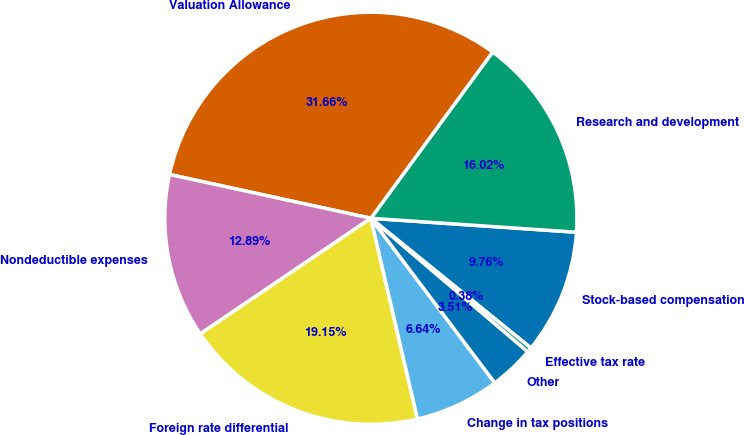Convert chart. <chart><loc_0><loc_0><loc_500><loc_500><pie_chart><fcel>Stock-based compensation<fcel>Research and development<fcel>Valuation Allowance<fcel>Nondeductible expenses<fcel>Foreign rate differential<fcel>Change in tax positions<fcel>Other<fcel>Effective tax rate<nl><fcel>9.76%<fcel>16.02%<fcel>31.66%<fcel>12.89%<fcel>19.15%<fcel>6.64%<fcel>3.51%<fcel>0.38%<nl></chart> 